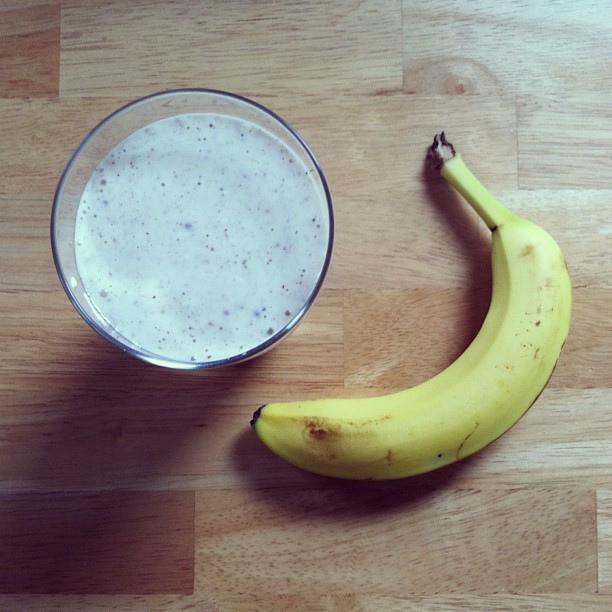How many bananas are in the photo?
Give a very brief answer. 1. How many bananas are there?
Give a very brief answer. 1. How many apples are in the bowl beside the toaster oven?
Give a very brief answer. 0. 